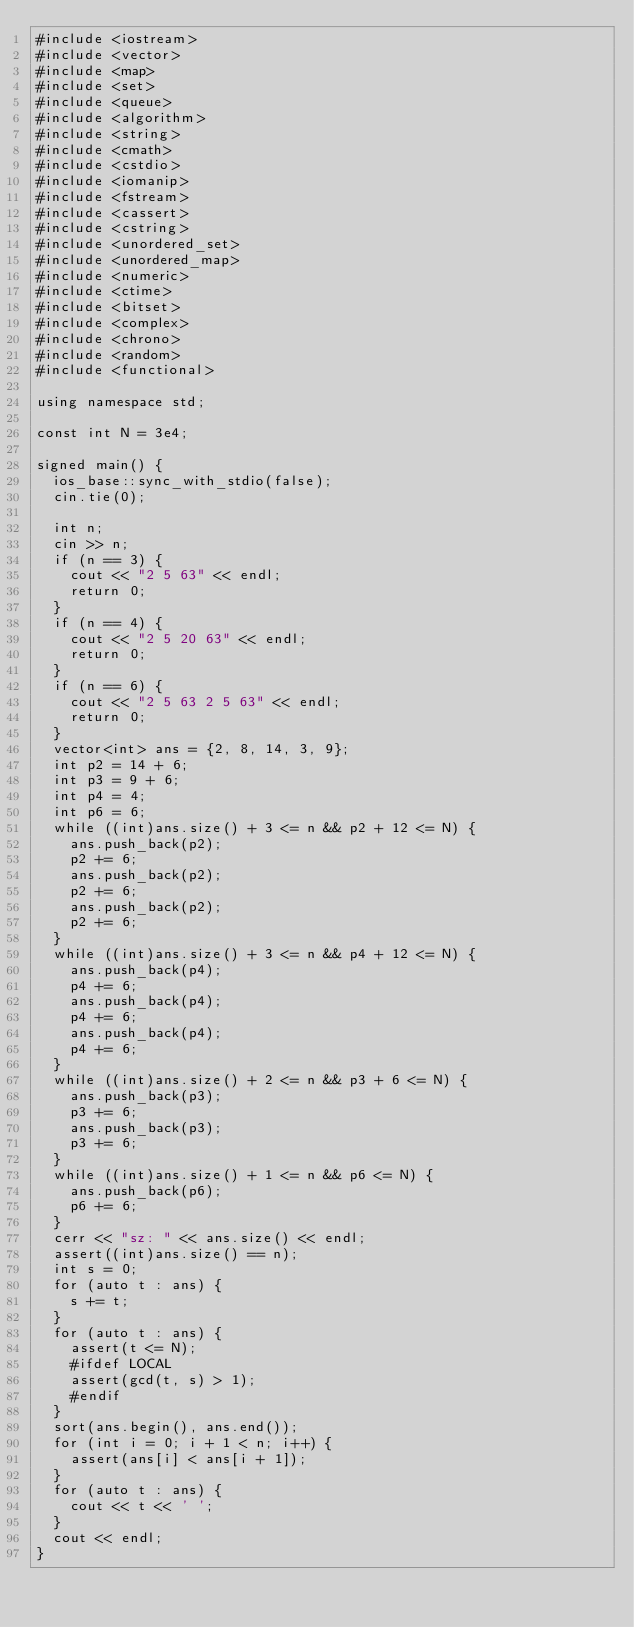<code> <loc_0><loc_0><loc_500><loc_500><_C++_>#include <iostream>
#include <vector>
#include <map>
#include <set>
#include <queue>
#include <algorithm>
#include <string>
#include <cmath>
#include <cstdio>
#include <iomanip>
#include <fstream>
#include <cassert>
#include <cstring>
#include <unordered_set>
#include <unordered_map>
#include <numeric>
#include <ctime>
#include <bitset>
#include <complex>
#include <chrono>
#include <random>
#include <functional>

using namespace std;

const int N = 3e4;

signed main() {
	ios_base::sync_with_stdio(false);
	cin.tie(0);	
	
	int n;
	cin >> n;
	if (n == 3) {
		cout << "2 5 63" << endl;
		return 0;
	}
	if (n == 4) {
		cout << "2 5 20 63" << endl;
		return 0;
	}
	if (n == 6) {
		cout << "2 5 63 2 5 63" << endl;
		return 0;
	}
	vector<int> ans = {2, 8, 14, 3, 9};
	int p2 = 14 + 6;
	int p3 = 9 + 6;
	int p4 = 4;
	int p6 = 6;
	while ((int)ans.size() + 3 <= n && p2 + 12 <= N) {
		ans.push_back(p2);
		p2 += 6;
		ans.push_back(p2);
		p2 += 6;
		ans.push_back(p2);
		p2 += 6;	
	}
	while ((int)ans.size() + 3 <= n && p4 + 12 <= N) {
		ans.push_back(p4);
		p4 += 6;
		ans.push_back(p4);
		p4 += 6;
		ans.push_back(p4);
		p4 += 6;	
	}
	while ((int)ans.size() + 2 <= n && p3 + 6 <= N) {
		ans.push_back(p3);
		p3 += 6;
		ans.push_back(p3);
		p3 += 6;
	}
	while ((int)ans.size() + 1 <= n && p6 <= N) {
		ans.push_back(p6);
		p6 += 6;
	}
	cerr << "sz: " << ans.size() << endl;
	assert((int)ans.size() == n);
	int s = 0;
	for (auto t : ans) {
		s += t;
	}
	for (auto t : ans) {
		assert(t <= N);
		#ifdef LOCAL
		assert(gcd(t, s) > 1);
		#endif
	}
	sort(ans.begin(), ans.end());
	for (int i = 0; i + 1 < n; i++) {
		assert(ans[i] < ans[i + 1]);
	}
	for (auto t : ans) {
		cout << t << ' ';
	} 
	cout << endl;
}
</code> 